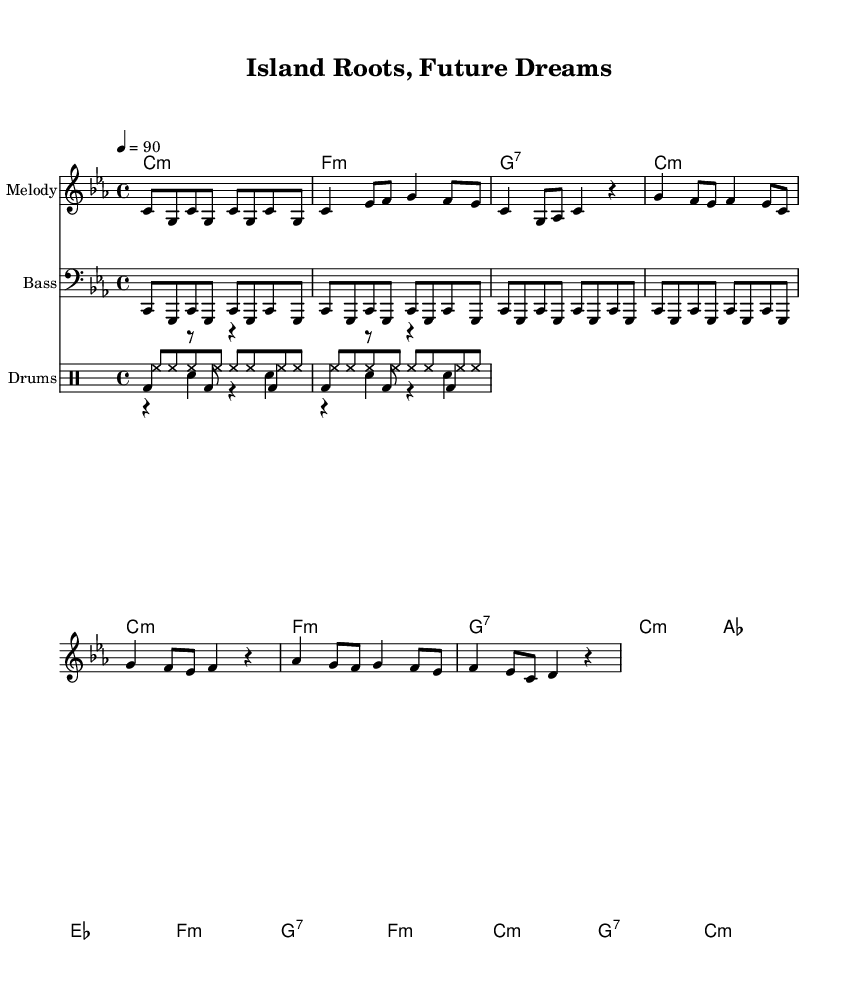What is the key signature of this music? The key signature is C minor, which includes the notes B flat, E flat, and A flat. This can be found at the beginning of the score, indicating that the piece is set in C minor.
Answer: C minor What is the time signature of this music? The time signature is 4/4, which indicates that there are four beats in each measure and the quarter note gets one beat. This can be identified at the beginning of the score.
Answer: 4/4 What is the tempo marking for this piece? The tempo marking indicates that the music is to be played at a speed of 90 beats per minute. This is noted in the score as 4 = 90, showing that the quarter note gets 90 beats per minute.
Answer: 90 How many measures are in the chorus section? The chorus section contains 4 measures, which can be counted directly from the music notation provided in that section. Each measure is visually separated by bar lines.
Answer: 4 Which instruments are played in this composition? The composition features a melody, bass, and drums. This can be determined by looking at the different staves and their respective instrument names at the beginning of each.
Answer: Melody, Bass, Drums What type of music does this piece represent? This piece represents Rap music, as indicated by its lyrical themes and rhythmic structure, which are characteristic of the genre. This understanding of music style comes from both the musical elements present and its title.
Answer: Rap How many notes are played in the intro? The intro features 8 notes, which can be counted from the melodic line shown at the beginning of the score. Each note is clearly notated and separated by rhythm.
Answer: 8 